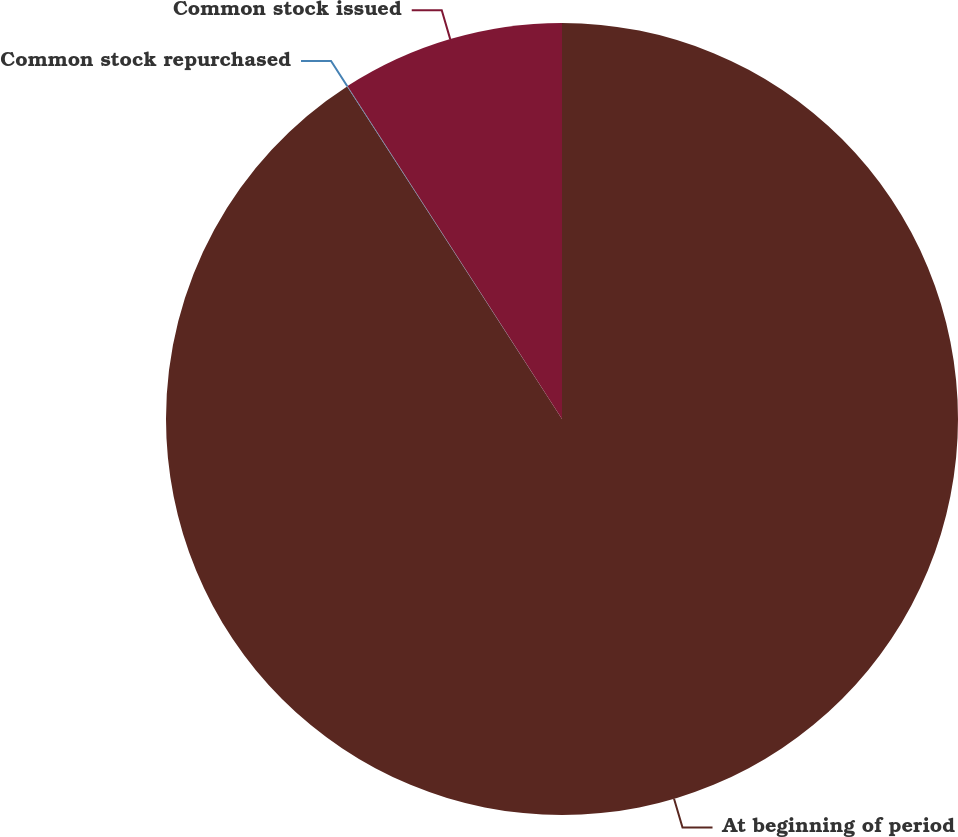Convert chart to OTSL. <chart><loc_0><loc_0><loc_500><loc_500><pie_chart><fcel>At beginning of period<fcel>Common stock repurchased<fcel>Common stock issued<nl><fcel>90.87%<fcel>0.02%<fcel>9.11%<nl></chart> 